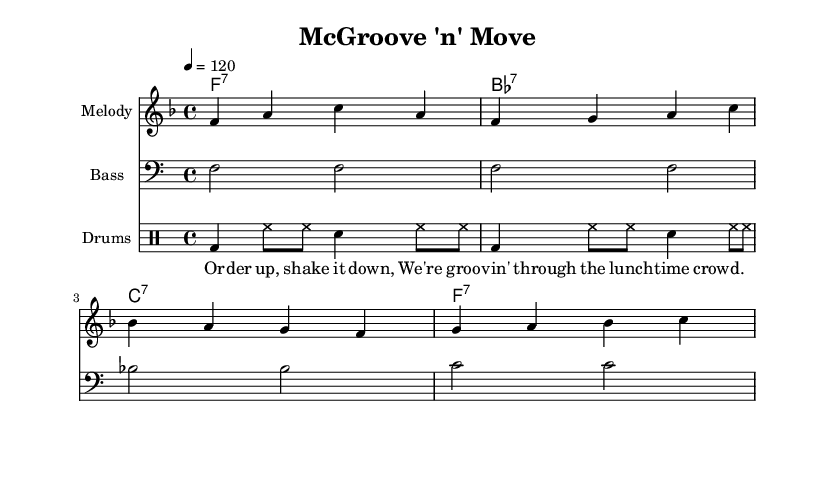What is the key signature of this music? The key signature is F major, which has one flat (B flat). This is indicated by the presence of a flat sign on the B line in the key signature section of the staff.
Answer: F major What is the time signature of this music? The time signature is 4/4, which means there are four beats in a measure and the quarter note gets one beat. This is indicated at the beginning of the sheet music next to the key signature.
Answer: 4/4 What is the tempo marking for this piece? The tempo marking is indicated by the number after the word "tempo," which states that the piece should be played at a moderate pace of 120 beats per minute. This is shown at the top of the sheet music.
Answer: 120 How many measures are in the melody section? The melody is divided into four measures, each indicated by vertical lines separating the notes. Counting those lines will reveal that there are four distinct measures of melody.
Answer: 4 What instrument is indicated for the melody? The instrument labeled for the melody staff is simply "Melody," showing that this part is designated for a melodic instrument like a voice or lead instrument to play. This is located at the beginning of the corresponding staff.
Answer: Melody What type of song is represented in this sheet music? The song is a disco song, which is characterized by its upbeat rhythm and celebratory lyrics. The title "McGroove 'n' Move" and the lyrics about grooving through a lunch crowd indicate its disco influence and lively theme.
Answer: Disco What rhythmic pattern is used in the drum section? The drum pattern consists primarily of bass drum hits on the downbeats and hi-hat and snare accents filling in the off-beats, creating a lively, danceable rhythm typical in disco. This pattern is shown in the drum staff section, which outlines the distinctive rhythm.
Answer: Bass and hi-hat pattern 